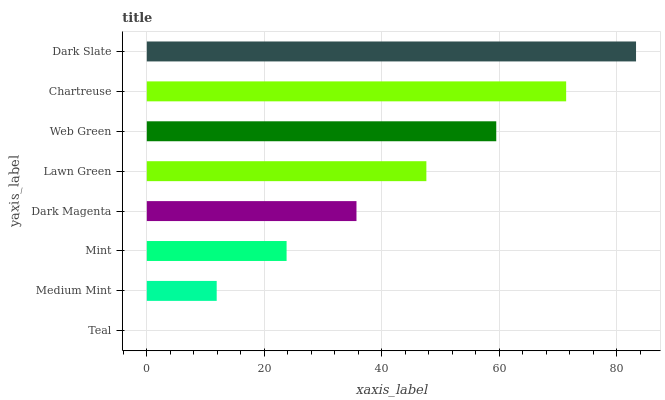Is Teal the minimum?
Answer yes or no. Yes. Is Dark Slate the maximum?
Answer yes or no. Yes. Is Medium Mint the minimum?
Answer yes or no. No. Is Medium Mint the maximum?
Answer yes or no. No. Is Medium Mint greater than Teal?
Answer yes or no. Yes. Is Teal less than Medium Mint?
Answer yes or no. Yes. Is Teal greater than Medium Mint?
Answer yes or no. No. Is Medium Mint less than Teal?
Answer yes or no. No. Is Lawn Green the high median?
Answer yes or no. Yes. Is Dark Magenta the low median?
Answer yes or no. Yes. Is Chartreuse the high median?
Answer yes or no. No. Is Lawn Green the low median?
Answer yes or no. No. 